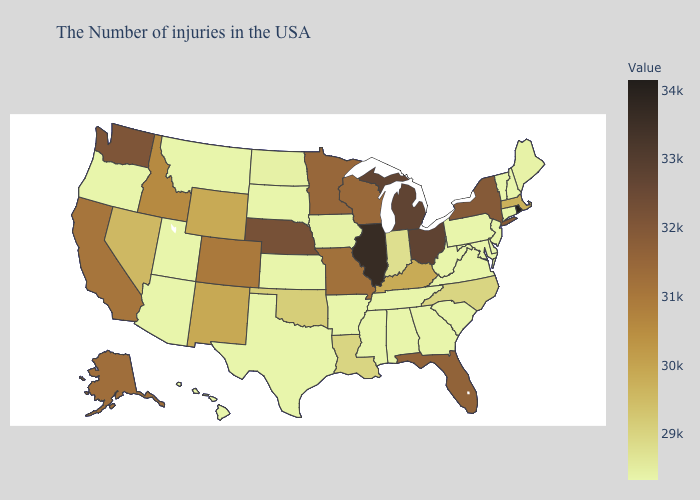Does Vermont have the highest value in the USA?
Concise answer only. No. Does Indiana have the highest value in the USA?
Answer briefly. No. Is the legend a continuous bar?
Be succinct. Yes. Does Vermont have a lower value than Ohio?
Write a very short answer. Yes. Among the states that border North Dakota , does Minnesota have the lowest value?
Answer briefly. No. 